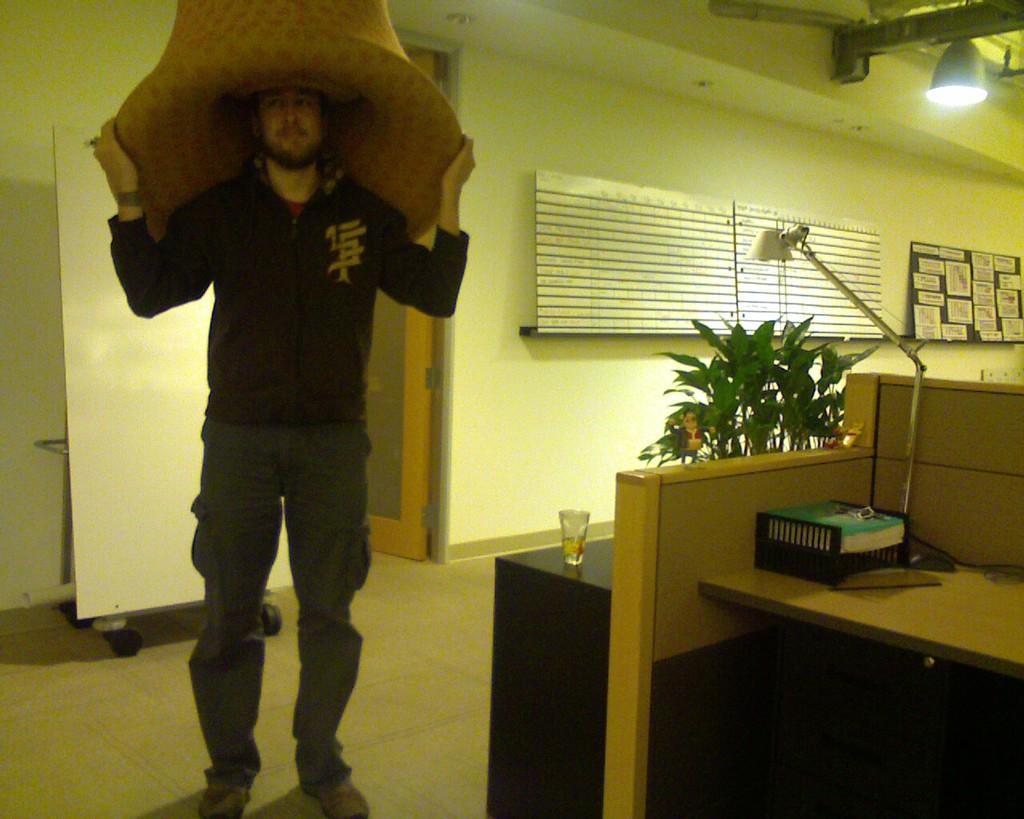Can you describe this image briefly? The person standing on the left side of this is wearing a black color jacket and wearing a cap. There is a wall in the background. there is one lamp is kept on a table on the right side of this image and there is one glass and a plant is present on a table. There is a light at the top of this image and there is a door in the middle of this image and there is a floor at the bottom of this image. 